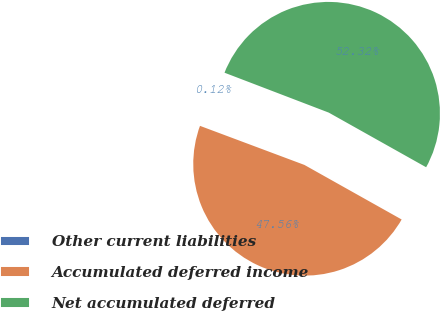Convert chart. <chart><loc_0><loc_0><loc_500><loc_500><pie_chart><fcel>Other current liabilities<fcel>Accumulated deferred income<fcel>Net accumulated deferred<nl><fcel>0.12%<fcel>47.56%<fcel>52.32%<nl></chart> 